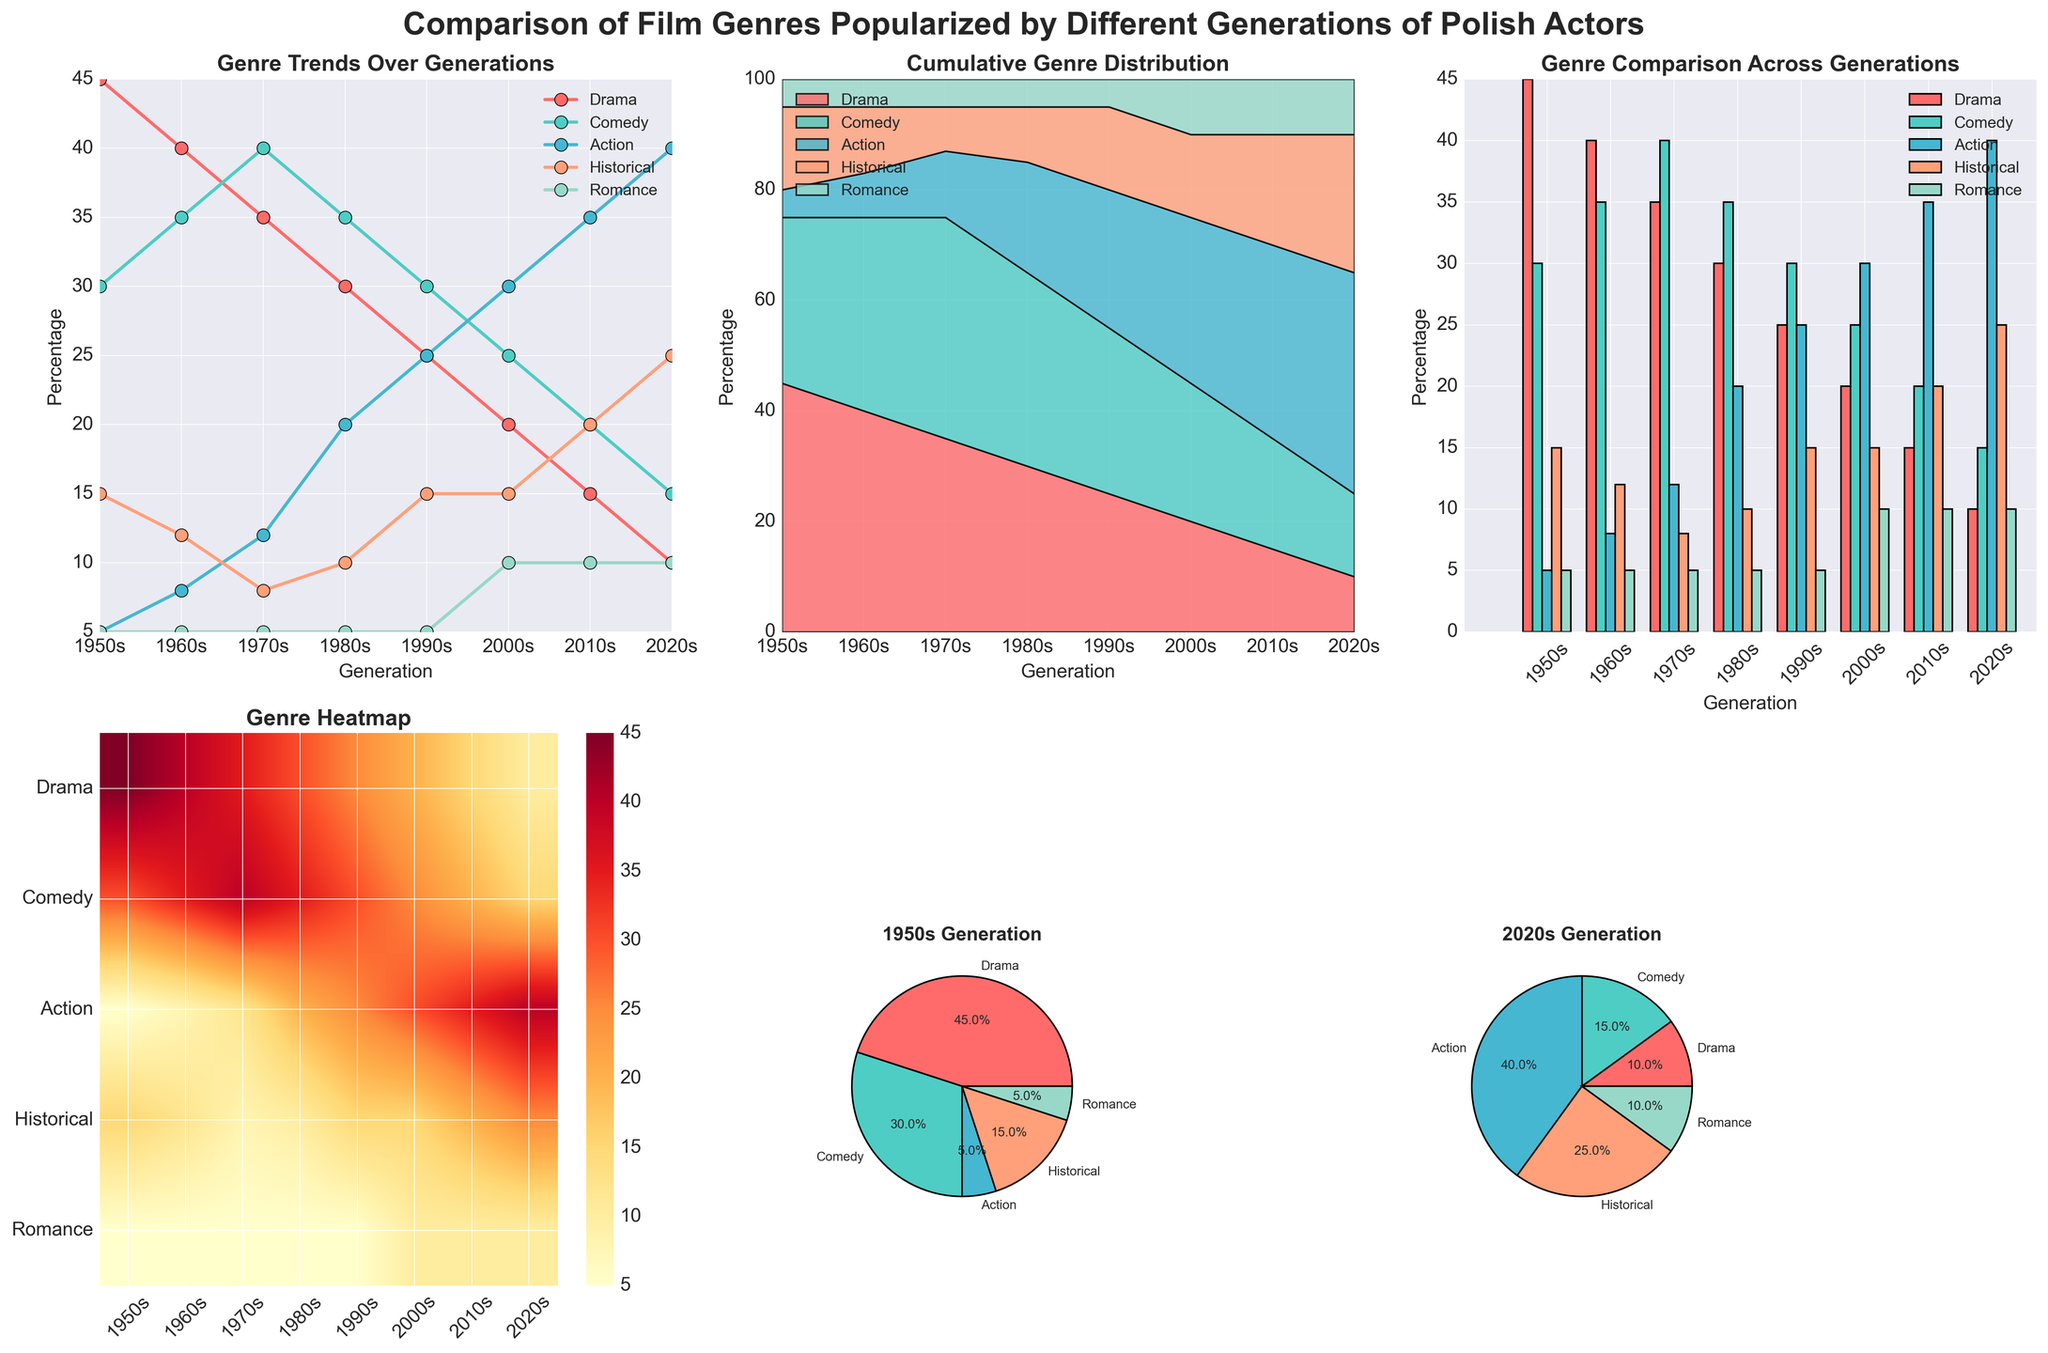what can we Learn from the grouped-bar plot about the shift in preference for drama movies? By observing the grouped-bar plot, we can see the decline in the percentage of drama movies across generations. In the 1950s, drama accounted for 45%, and this consistently decreased over the decades to just 10% in the 2020s. This indicates a decreasing preference for drama movies among newer generations of Polish actors.
Answer: Decreased preference Which generation has the highest percentage of action films according to the line plot? The line plot shows that the highest percentage of action films is in the 2020s generation. The "Action" genre line peaks at 40% in this generation.
Answer: 2020s Compare the percentage of historical films in the 1950s and 2000s according to the heatmap. In the heatmap, the 1950s show a historical film percentage of 15%, while the 2000s show 15%. By directly comparing the intensity of the color at the intersection of these generations and the historical genre axis, we can see that they are the same.
Answer: Equal According to the stacked area plot, in which decade did the cumulative percentage of comedy films surpass that of drama films? By looking at where the stacked area for comedy films exceeds the area for drama films, we can observe that this shift happens around the 1970s.
Answer: 1970s Which genre shows the least variation in percentages across all generations according to the grouped bar plot? The grouped bar plot suggests that the Romance genre shows the least variation, with percentages consistently around 5-10% across all generations.
Answer: Romance Calculate the average percentage of Historical films over all generations using the line plot. From the line plot, the percentages of historical films are as follows: 15, 12, 8, 10, 15, 15, 20, 25. Summing these gives 120, and there are 8 generations, so the average is 120/8.
Answer: 15% In the heatmap, which genre shows the highest variability in color intensity across generations, and what does this indicate? The "Drama" genre shows the highest variability in color intensity, indicating greater fluctuations in its percentage across different generations.
Answer: Drama 